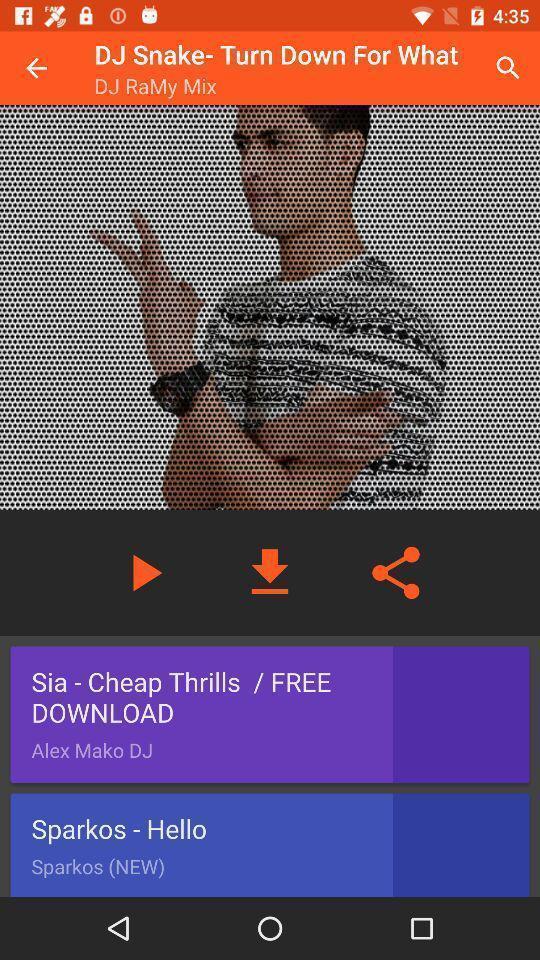Describe the visual elements of this screenshot. Screen displaying multiple controls of a song. 